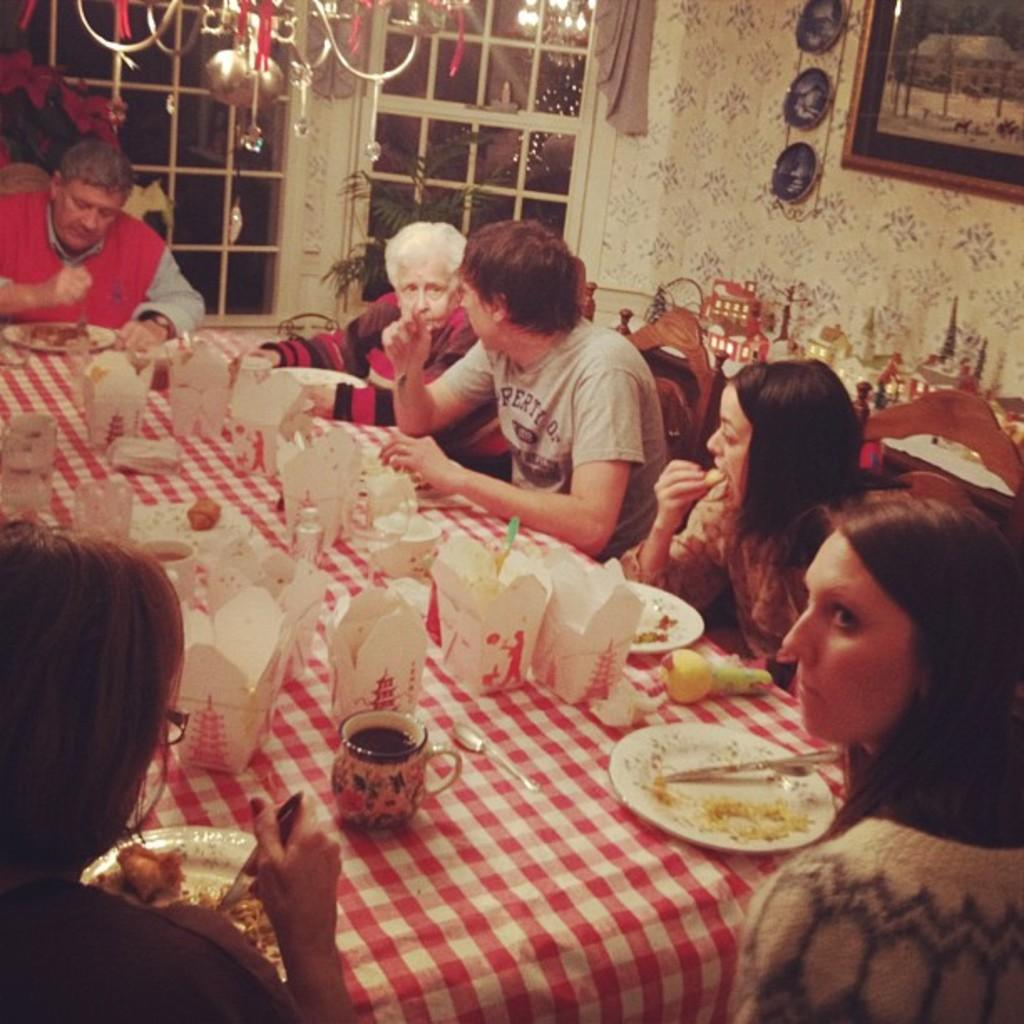How many people are in the image? There is a group of people in the image, but the exact number is not specified. What are the people in the image doing? The people in the image are having a meal. Where is the tub located in the image? There is no tub present in the image. What color are the grapes on the table in the image? There is no mention of grapes or a table in the image. 